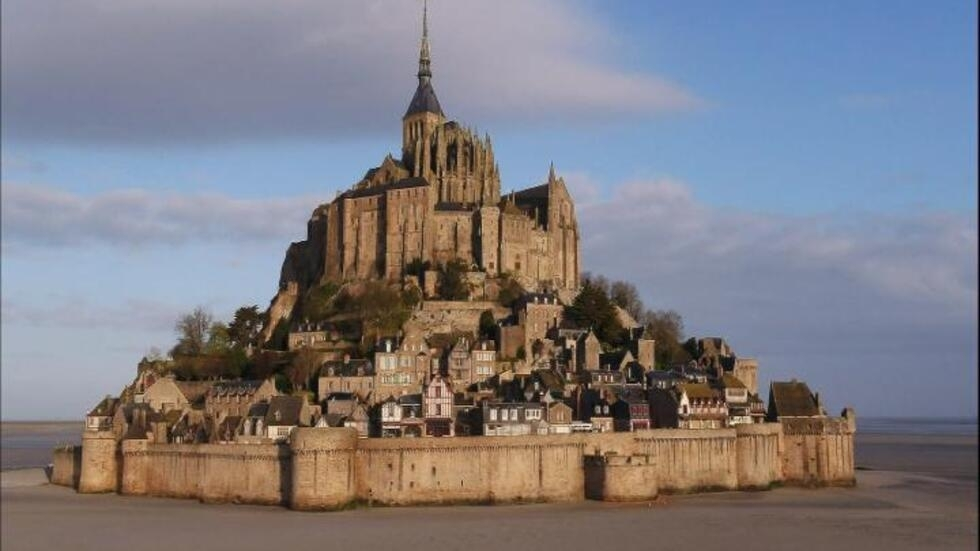What is this photo about? This stunning photograph depicts Mont Saint Michel in France, an iconic island commune known for its majestic medieval architecture. At the center of the image stands the striking abbey, topped with a towering spire that seems to touch the sky. This abbey, dating back to the 8th century, is surrounded by fortified walls, emblematic of its rich history and the strategic importance it held throughout the centuries. Nestled within these walls is a picturesque village, a charming cluster of traditional houses that add a bustling life to the scene. The overall tone of the image blends soft earth hues with the crisp blues of the surrounding sea and sky, creating a serene yet powerful visual experience. The photograph offers a full panoramic view, capturing not only the architectural magnificence but also the natural beauty of Mont Saint Michel. 